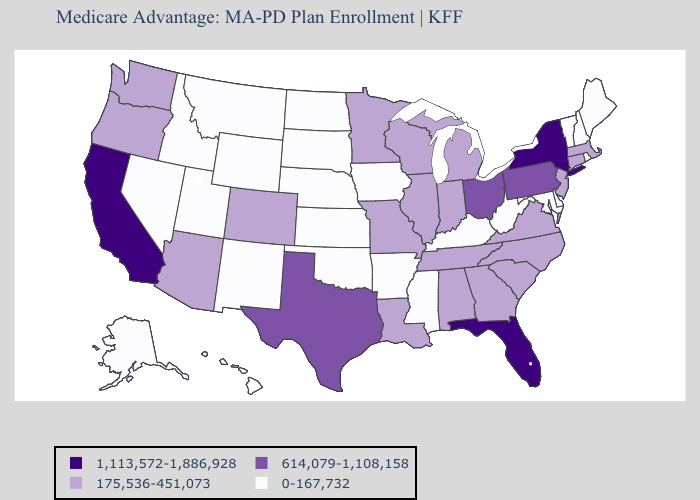What is the highest value in the USA?
Quick response, please. 1,113,572-1,886,928. Does Illinois have the highest value in the USA?
Answer briefly. No. Among the states that border Massachusetts , which have the lowest value?
Be succinct. New Hampshire, Rhode Island, Vermont. Name the states that have a value in the range 1,113,572-1,886,928?
Short answer required. California, Florida, New York. Does Wisconsin have the lowest value in the MidWest?
Keep it brief. No. Does Florida have a higher value than California?
Write a very short answer. No. Which states hav the highest value in the South?
Quick response, please. Florida. Which states hav the highest value in the Northeast?
Write a very short answer. New York. What is the highest value in states that border Idaho?
Write a very short answer. 175,536-451,073. What is the lowest value in the USA?
Write a very short answer. 0-167,732. What is the value of Wyoming?
Write a very short answer. 0-167,732. What is the value of Maine?
Write a very short answer. 0-167,732. What is the value of West Virginia?
Short answer required. 0-167,732. What is the value of New Jersey?
Short answer required. 175,536-451,073. 